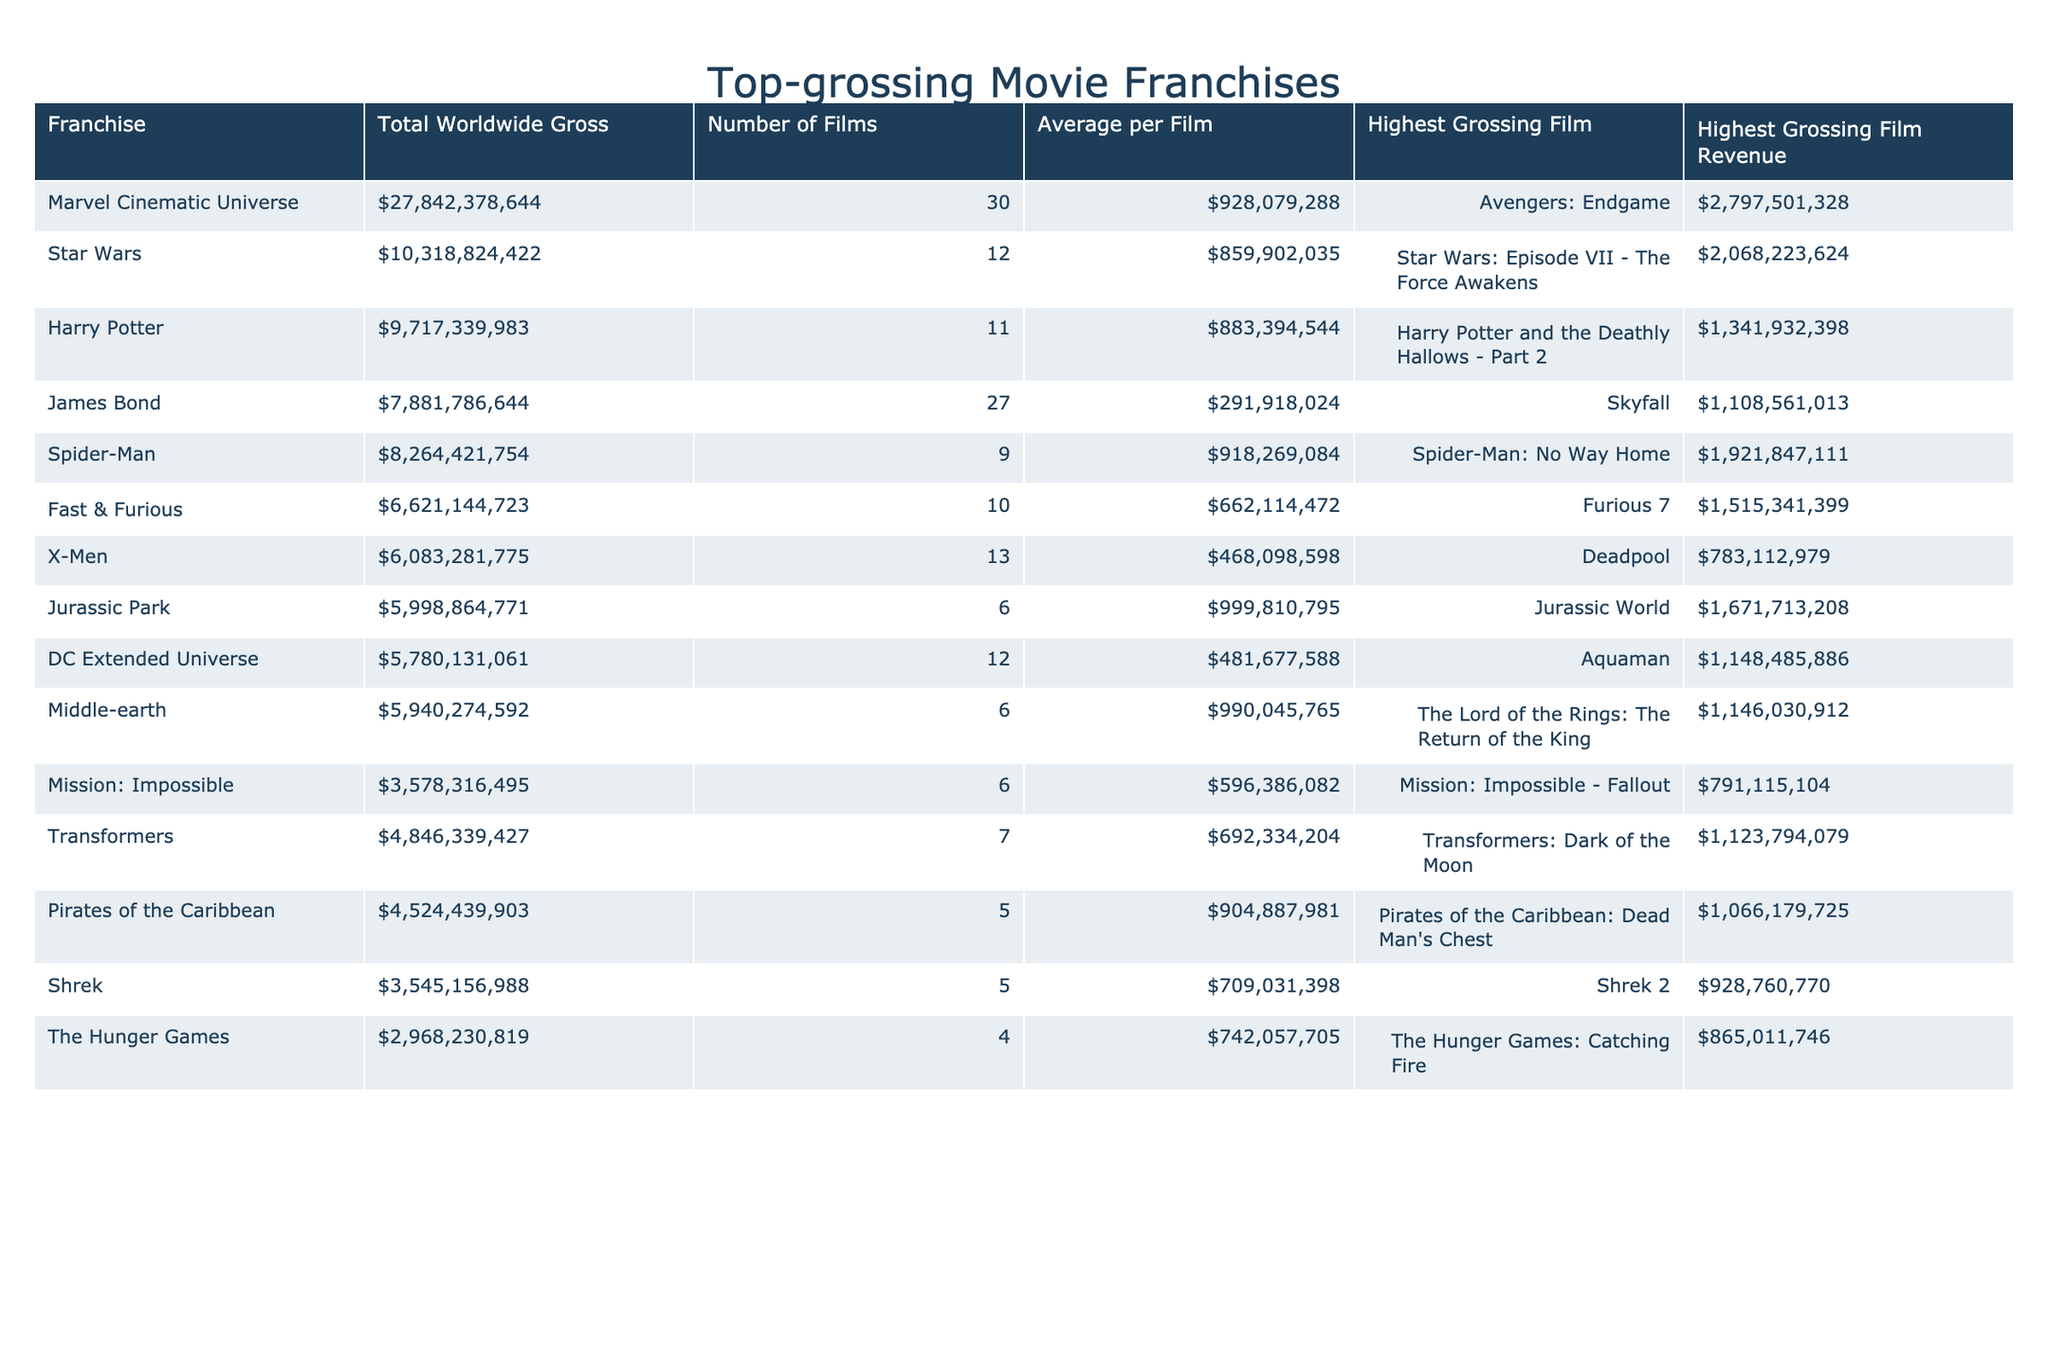What is the highest grossing film in the Marvel Cinematic Universe franchise? The table specifies "Avengers: Endgame" as the highest grossing film in the Marvel Cinematic Universe.
Answer: Avengers: Endgame How many films are in the Harry Potter franchise? The table indicates that there are 11 films in the Harry Potter franchise.
Answer: 11 Which franchise has the highest average gross per film? By comparing the average gross per film across franchises, the Marvel Cinematic Universe with an average of $928,079,288 is the highest.
Answer: Marvel Cinematic Universe What is the total worldwide gross of the Fast & Furious franchise? The data shows that the total worldwide gross of the Fast & Furious franchise is $6,621,447,723.
Answer: $6,621,447,723 Which franchise has a higher total gross: Jurassic Park or Middle-earth? Comparing the totals, Jurassic Park has $5,998,864,771, and Middle-earth has $5,940,274,592. Jurassic Park has a higher total gross.
Answer: Jurassic Park Is there a film in the DC Extended Universe that grossed over $1 billion? The highest grossing film in the DC Extended Universe is "Aquaman" with revenue of $1,148,485,886, which is over $1 billion.
Answer: Yes What is the difference in the total worldwide gross between the Star Wars and Harry Potter franchises? The total worldwide gross for Star Wars is $10,318,824,422 and for Harry Potter is $9,717,339,983. The difference is $10,318,824,422 - $9,717,339,983 = $601,484,439.
Answer: $601,484,439 Which franchise has the least grossing film and what is its revenue? The franchise with the least grossing film is the Pirates of the Caribbean, with total revenue of $4,524,439,903 and the highest grossing film revenue at $1,066,179,725.
Answer: Pirates of the Caribbean, $1,066,179,725 How many franchises have a total worldwide gross exceeding $7 billion? By counting the entries in the table, the franchises that exceed $7 billion are Marvel Cinematic Universe, Star Wars, Harry Potter, and James Bond, totaling 4 franchises.
Answer: 4 Which franchise has the highest grossing film and what is its revenue? The Marvel Cinematic Universe has the highest grossing film, "Avengers: Endgame," with a revenue of $2,797,501,328.
Answer: Avengers: Endgame, $2,797,501,328 